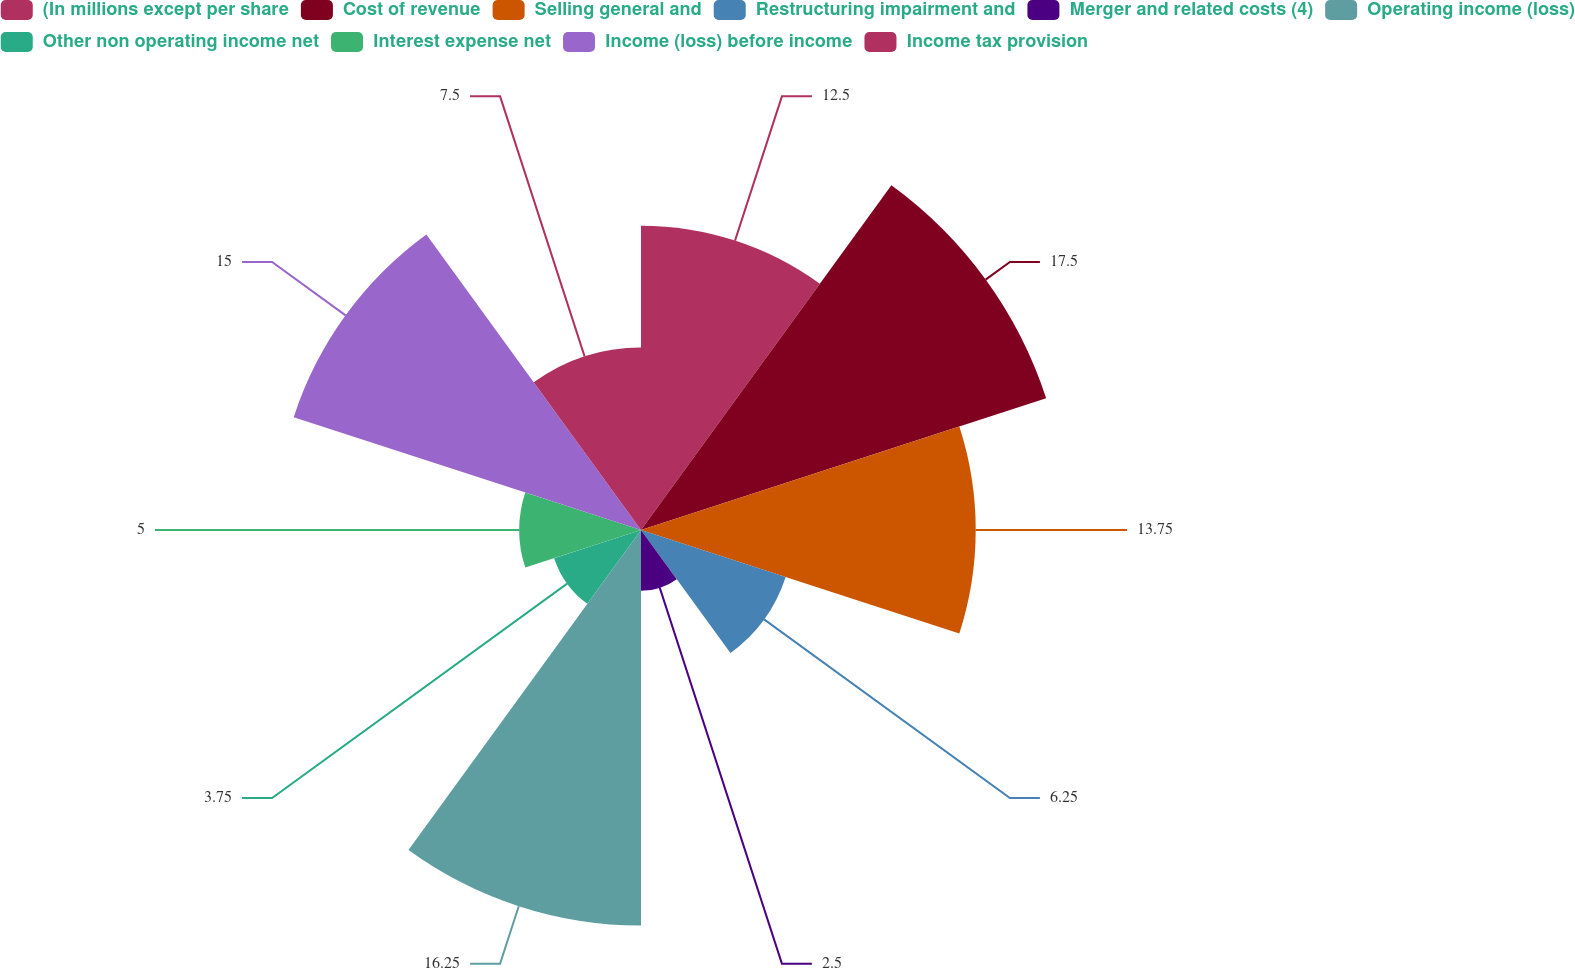<chart> <loc_0><loc_0><loc_500><loc_500><pie_chart><fcel>(In millions except per share<fcel>Cost of revenue<fcel>Selling general and<fcel>Restructuring impairment and<fcel>Merger and related costs (4)<fcel>Operating income (loss)<fcel>Other non operating income net<fcel>Interest expense net<fcel>Income (loss) before income<fcel>Income tax provision<nl><fcel>12.5%<fcel>17.5%<fcel>13.75%<fcel>6.25%<fcel>2.5%<fcel>16.25%<fcel>3.75%<fcel>5.0%<fcel>15.0%<fcel>7.5%<nl></chart> 